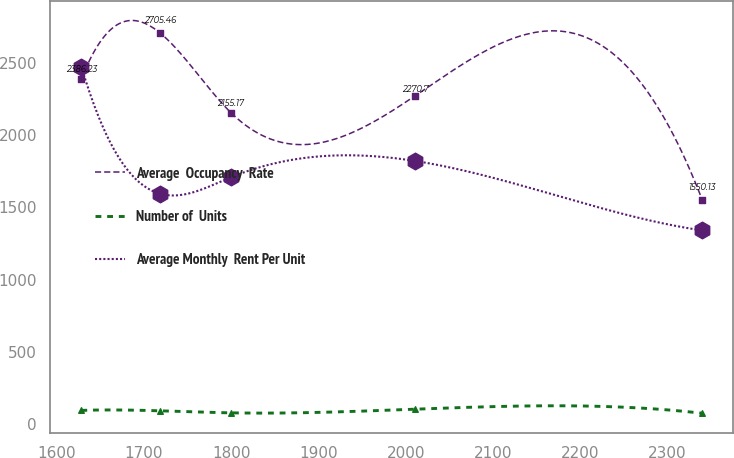<chart> <loc_0><loc_0><loc_500><loc_500><line_chart><ecel><fcel>Average  Occupancy  Rate<fcel>Number of  Units<fcel>Average Monthly  Rent Per Unit<nl><fcel>1628.23<fcel>2386.23<fcel>96.13<fcel>2473.19<nl><fcel>1718.41<fcel>2705.46<fcel>93.32<fcel>1593.9<nl><fcel>1799.5<fcel>2155.17<fcel>79.18<fcel>1707.19<nl><fcel>2010.68<fcel>2270.7<fcel>104.5<fcel>1820.48<nl><fcel>2339.86<fcel>1550.13<fcel>76.37<fcel>1340.34<nl></chart> 